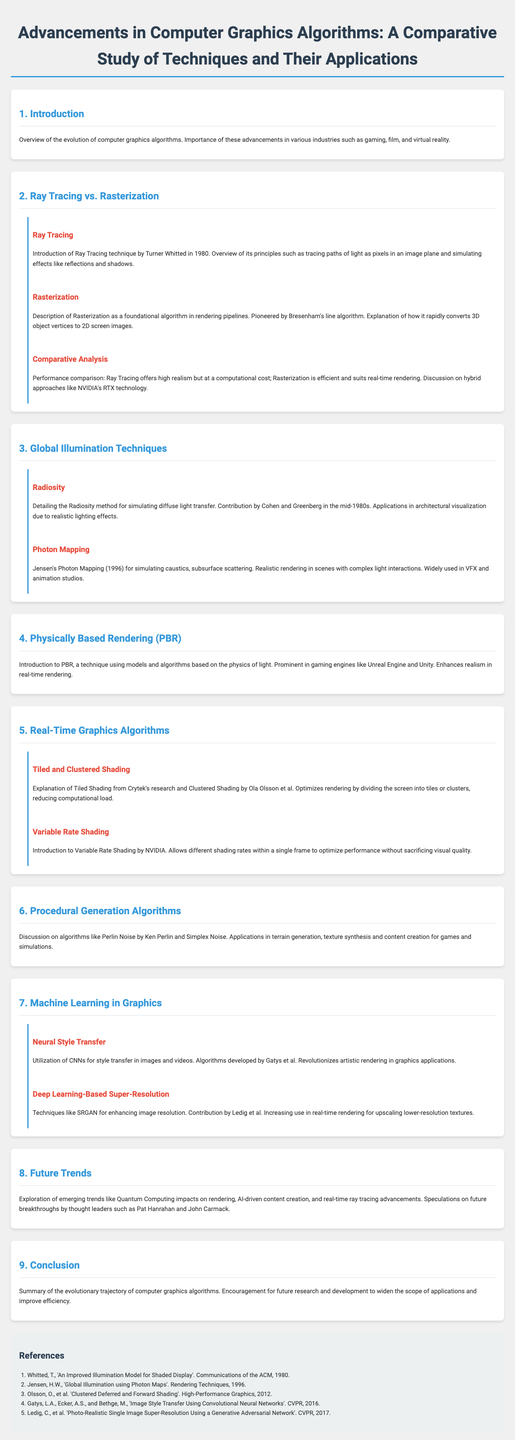What is the title of the document? The title is prominently stated at the top of the document, summarizing its main focus.
Answer: Advancements in Computer Graphics Algorithms: A Comparative Study of Techniques and Their Applications Who introduced the Ray Tracing technique? The document references the original contributor of the Ray Tracing technique and the year it was introduced.
Answer: Turner Whitted What year was Photon Mapping introduced? The document specifies the year when Photon Mapping was developed by Jensen.
Answer: 1996 What is a key benefit of using Rasterization? The document discusses the efficiency and speed advantages of Rasterization in rendering.
Answer: Efficient What does PBR stand for? The term is used within the context of rendering in the document and is defined in the related section.
Answer: Physically Based Rendering In which section is Machine Learning discussed? The document is structured into sections, and this identifies where Machine Learning is covered.
Answer: 7 What is the primary application of Radiosity? The document highlights the main use case of the Radiosity method within its context.
Answer: Architectural visualization What are the two algorithms mentioned under Procedural Generation? The document lists specific algorithms used in this category.
Answer: Perlin Noise and Simplex Noise How does Variable Rate Shading help performance? The explanation in the document clarifies the advantage of this technique in rendering.
Answer: Optimizes performance without sacrificing visual quality 